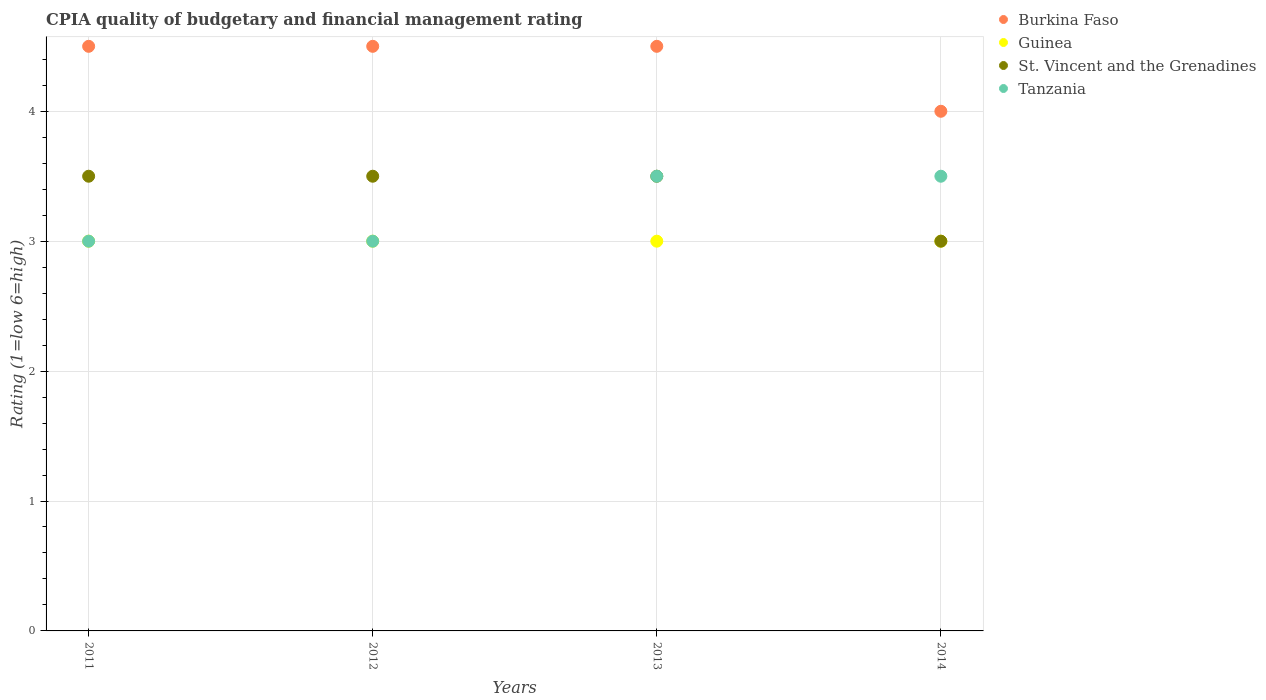How many different coloured dotlines are there?
Your answer should be compact. 4. Across all years, what is the maximum CPIA rating in Guinea?
Provide a succinct answer. 3. Across all years, what is the minimum CPIA rating in Guinea?
Make the answer very short. 3. What is the total CPIA rating in Tanzania in the graph?
Ensure brevity in your answer.  13. What is the difference between the CPIA rating in Guinea in 2013 and the CPIA rating in Burkina Faso in 2014?
Ensure brevity in your answer.  -1. What is the average CPIA rating in Tanzania per year?
Your answer should be compact. 3.25. In how many years, is the CPIA rating in Burkina Faso greater than 1.4?
Offer a terse response. 4. What is the ratio of the CPIA rating in Tanzania in 2011 to that in 2013?
Provide a succinct answer. 0.86. Is the difference between the CPIA rating in Tanzania in 2013 and 2014 greater than the difference between the CPIA rating in Guinea in 2013 and 2014?
Provide a short and direct response. No. What is the difference between the highest and the lowest CPIA rating in Burkina Faso?
Your response must be concise. 0.5. In how many years, is the CPIA rating in Burkina Faso greater than the average CPIA rating in Burkina Faso taken over all years?
Your response must be concise. 3. Is it the case that in every year, the sum of the CPIA rating in Burkina Faso and CPIA rating in Guinea  is greater than the sum of CPIA rating in St. Vincent and the Grenadines and CPIA rating in Tanzania?
Provide a short and direct response. Yes. Is it the case that in every year, the sum of the CPIA rating in Burkina Faso and CPIA rating in St. Vincent and the Grenadines  is greater than the CPIA rating in Guinea?
Your answer should be very brief. Yes. Does the CPIA rating in Tanzania monotonically increase over the years?
Your response must be concise. No. Is the CPIA rating in Tanzania strictly greater than the CPIA rating in Burkina Faso over the years?
Make the answer very short. No. Is the CPIA rating in Tanzania strictly less than the CPIA rating in St. Vincent and the Grenadines over the years?
Your response must be concise. No. How many dotlines are there?
Your response must be concise. 4. How many years are there in the graph?
Make the answer very short. 4. What is the difference between two consecutive major ticks on the Y-axis?
Offer a very short reply. 1. Are the values on the major ticks of Y-axis written in scientific E-notation?
Offer a terse response. No. What is the title of the graph?
Provide a short and direct response. CPIA quality of budgetary and financial management rating. Does "North America" appear as one of the legend labels in the graph?
Your answer should be compact. No. What is the label or title of the Y-axis?
Provide a short and direct response. Rating (1=low 6=high). What is the Rating (1=low 6=high) of Guinea in 2011?
Provide a short and direct response. 3. What is the Rating (1=low 6=high) of St. Vincent and the Grenadines in 2011?
Give a very brief answer. 3.5. What is the Rating (1=low 6=high) in Tanzania in 2011?
Offer a very short reply. 3. What is the Rating (1=low 6=high) of Burkina Faso in 2012?
Provide a short and direct response. 4.5. What is the Rating (1=low 6=high) in Guinea in 2012?
Your answer should be compact. 3. What is the Rating (1=low 6=high) in St. Vincent and the Grenadines in 2013?
Ensure brevity in your answer.  3.5. What is the Rating (1=low 6=high) of Tanzania in 2013?
Your response must be concise. 3.5. What is the Rating (1=low 6=high) in Tanzania in 2014?
Provide a short and direct response. 3.5. Across all years, what is the maximum Rating (1=low 6=high) in Burkina Faso?
Give a very brief answer. 4.5. Across all years, what is the maximum Rating (1=low 6=high) of Guinea?
Your answer should be compact. 3. Across all years, what is the maximum Rating (1=low 6=high) of Tanzania?
Provide a short and direct response. 3.5. Across all years, what is the minimum Rating (1=low 6=high) of Guinea?
Your response must be concise. 3. Across all years, what is the minimum Rating (1=low 6=high) in Tanzania?
Provide a short and direct response. 3. What is the total Rating (1=low 6=high) in Guinea in the graph?
Keep it short and to the point. 12. What is the difference between the Rating (1=low 6=high) of Burkina Faso in 2011 and that in 2012?
Make the answer very short. 0. What is the difference between the Rating (1=low 6=high) in St. Vincent and the Grenadines in 2011 and that in 2012?
Your response must be concise. 0. What is the difference between the Rating (1=low 6=high) of Tanzania in 2011 and that in 2012?
Offer a terse response. 0. What is the difference between the Rating (1=low 6=high) of St. Vincent and the Grenadines in 2011 and that in 2013?
Make the answer very short. 0. What is the difference between the Rating (1=low 6=high) of Guinea in 2011 and that in 2014?
Provide a succinct answer. 0. What is the difference between the Rating (1=low 6=high) of St. Vincent and the Grenadines in 2011 and that in 2014?
Provide a succinct answer. 0.5. What is the difference between the Rating (1=low 6=high) of Burkina Faso in 2012 and that in 2013?
Ensure brevity in your answer.  0. What is the difference between the Rating (1=low 6=high) of Tanzania in 2012 and that in 2013?
Your answer should be compact. -0.5. What is the difference between the Rating (1=low 6=high) in St. Vincent and the Grenadines in 2012 and that in 2014?
Make the answer very short. 0.5. What is the difference between the Rating (1=low 6=high) in Tanzania in 2012 and that in 2014?
Provide a succinct answer. -0.5. What is the difference between the Rating (1=low 6=high) in Burkina Faso in 2013 and that in 2014?
Keep it short and to the point. 0.5. What is the difference between the Rating (1=low 6=high) of Guinea in 2013 and that in 2014?
Give a very brief answer. 0. What is the difference between the Rating (1=low 6=high) of Tanzania in 2013 and that in 2014?
Make the answer very short. 0. What is the difference between the Rating (1=low 6=high) of Burkina Faso in 2011 and the Rating (1=low 6=high) of Guinea in 2012?
Offer a very short reply. 1.5. What is the difference between the Rating (1=low 6=high) of St. Vincent and the Grenadines in 2011 and the Rating (1=low 6=high) of Tanzania in 2012?
Your response must be concise. 0.5. What is the difference between the Rating (1=low 6=high) in Burkina Faso in 2011 and the Rating (1=low 6=high) in Guinea in 2013?
Your response must be concise. 1.5. What is the difference between the Rating (1=low 6=high) in Guinea in 2011 and the Rating (1=low 6=high) in St. Vincent and the Grenadines in 2013?
Keep it short and to the point. -0.5. What is the difference between the Rating (1=low 6=high) of Guinea in 2011 and the Rating (1=low 6=high) of Tanzania in 2013?
Keep it short and to the point. -0.5. What is the difference between the Rating (1=low 6=high) of Burkina Faso in 2011 and the Rating (1=low 6=high) of St. Vincent and the Grenadines in 2014?
Your answer should be very brief. 1.5. What is the difference between the Rating (1=low 6=high) of Guinea in 2011 and the Rating (1=low 6=high) of Tanzania in 2014?
Your answer should be very brief. -0.5. What is the difference between the Rating (1=low 6=high) of St. Vincent and the Grenadines in 2011 and the Rating (1=low 6=high) of Tanzania in 2014?
Provide a succinct answer. 0. What is the difference between the Rating (1=low 6=high) in Burkina Faso in 2012 and the Rating (1=low 6=high) in Guinea in 2013?
Offer a very short reply. 1.5. What is the difference between the Rating (1=low 6=high) of Burkina Faso in 2012 and the Rating (1=low 6=high) of St. Vincent and the Grenadines in 2013?
Offer a terse response. 1. What is the difference between the Rating (1=low 6=high) in Burkina Faso in 2012 and the Rating (1=low 6=high) in Tanzania in 2013?
Provide a succinct answer. 1. What is the difference between the Rating (1=low 6=high) of Guinea in 2012 and the Rating (1=low 6=high) of Tanzania in 2013?
Your answer should be very brief. -0.5. What is the difference between the Rating (1=low 6=high) of Guinea in 2012 and the Rating (1=low 6=high) of St. Vincent and the Grenadines in 2014?
Keep it short and to the point. 0. What is the difference between the Rating (1=low 6=high) of St. Vincent and the Grenadines in 2012 and the Rating (1=low 6=high) of Tanzania in 2014?
Offer a terse response. 0. What is the difference between the Rating (1=low 6=high) in Burkina Faso in 2013 and the Rating (1=low 6=high) in St. Vincent and the Grenadines in 2014?
Your answer should be compact. 1.5. What is the difference between the Rating (1=low 6=high) in Guinea in 2013 and the Rating (1=low 6=high) in St. Vincent and the Grenadines in 2014?
Give a very brief answer. 0. What is the difference between the Rating (1=low 6=high) in Guinea in 2013 and the Rating (1=low 6=high) in Tanzania in 2014?
Your answer should be compact. -0.5. What is the difference between the Rating (1=low 6=high) in St. Vincent and the Grenadines in 2013 and the Rating (1=low 6=high) in Tanzania in 2014?
Offer a terse response. 0. What is the average Rating (1=low 6=high) in Burkina Faso per year?
Offer a terse response. 4.38. What is the average Rating (1=low 6=high) of St. Vincent and the Grenadines per year?
Provide a succinct answer. 3.38. What is the average Rating (1=low 6=high) of Tanzania per year?
Give a very brief answer. 3.25. In the year 2011, what is the difference between the Rating (1=low 6=high) in Burkina Faso and Rating (1=low 6=high) in Guinea?
Your answer should be compact. 1.5. In the year 2011, what is the difference between the Rating (1=low 6=high) in Burkina Faso and Rating (1=low 6=high) in Tanzania?
Give a very brief answer. 1.5. In the year 2011, what is the difference between the Rating (1=low 6=high) of Guinea and Rating (1=low 6=high) of St. Vincent and the Grenadines?
Your response must be concise. -0.5. In the year 2012, what is the difference between the Rating (1=low 6=high) of Guinea and Rating (1=low 6=high) of Tanzania?
Your answer should be very brief. 0. In the year 2012, what is the difference between the Rating (1=low 6=high) of St. Vincent and the Grenadines and Rating (1=low 6=high) of Tanzania?
Offer a very short reply. 0.5. In the year 2013, what is the difference between the Rating (1=low 6=high) of Burkina Faso and Rating (1=low 6=high) of St. Vincent and the Grenadines?
Your response must be concise. 1. In the year 2013, what is the difference between the Rating (1=low 6=high) of Burkina Faso and Rating (1=low 6=high) of Tanzania?
Your answer should be very brief. 1. In the year 2013, what is the difference between the Rating (1=low 6=high) in Guinea and Rating (1=low 6=high) in St. Vincent and the Grenadines?
Give a very brief answer. -0.5. In the year 2014, what is the difference between the Rating (1=low 6=high) of Burkina Faso and Rating (1=low 6=high) of Guinea?
Offer a very short reply. 1. In the year 2014, what is the difference between the Rating (1=low 6=high) in Burkina Faso and Rating (1=low 6=high) in Tanzania?
Keep it short and to the point. 0.5. In the year 2014, what is the difference between the Rating (1=low 6=high) of St. Vincent and the Grenadines and Rating (1=low 6=high) of Tanzania?
Offer a terse response. -0.5. What is the ratio of the Rating (1=low 6=high) in Tanzania in 2011 to that in 2012?
Offer a very short reply. 1. What is the ratio of the Rating (1=low 6=high) of Guinea in 2011 to that in 2013?
Make the answer very short. 1. What is the ratio of the Rating (1=low 6=high) of Tanzania in 2011 to that in 2013?
Give a very brief answer. 0.86. What is the ratio of the Rating (1=low 6=high) of Guinea in 2011 to that in 2014?
Provide a short and direct response. 1. What is the ratio of the Rating (1=low 6=high) in Burkina Faso in 2012 to that in 2013?
Make the answer very short. 1. What is the ratio of the Rating (1=low 6=high) of Guinea in 2012 to that in 2013?
Ensure brevity in your answer.  1. What is the ratio of the Rating (1=low 6=high) in Tanzania in 2012 to that in 2013?
Provide a short and direct response. 0.86. What is the ratio of the Rating (1=low 6=high) in Burkina Faso in 2012 to that in 2014?
Keep it short and to the point. 1.12. What is the ratio of the Rating (1=low 6=high) in Guinea in 2012 to that in 2014?
Your answer should be very brief. 1. What is the ratio of the Rating (1=low 6=high) in Tanzania in 2012 to that in 2014?
Offer a terse response. 0.86. What is the ratio of the Rating (1=low 6=high) of Burkina Faso in 2013 to that in 2014?
Your response must be concise. 1.12. What is the difference between the highest and the second highest Rating (1=low 6=high) in Guinea?
Offer a terse response. 0. What is the difference between the highest and the lowest Rating (1=low 6=high) in Guinea?
Provide a succinct answer. 0. What is the difference between the highest and the lowest Rating (1=low 6=high) in Tanzania?
Ensure brevity in your answer.  0.5. 